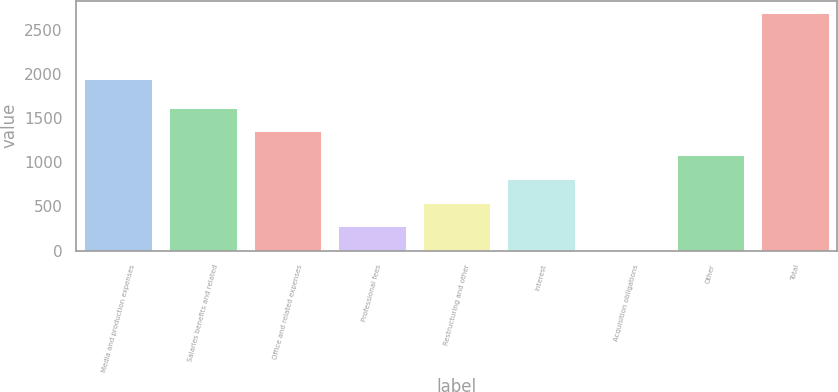<chart> <loc_0><loc_0><loc_500><loc_500><bar_chart><fcel>Media and production expenses<fcel>Salaries benefits and related<fcel>Office and related expenses<fcel>Professional fees<fcel>Restructuring and other<fcel>Interest<fcel>Acquisition obligations<fcel>Other<fcel>Total<nl><fcel>1943.5<fcel>1616.88<fcel>1348.3<fcel>273.98<fcel>542.56<fcel>811.14<fcel>5.4<fcel>1079.72<fcel>2691.2<nl></chart> 